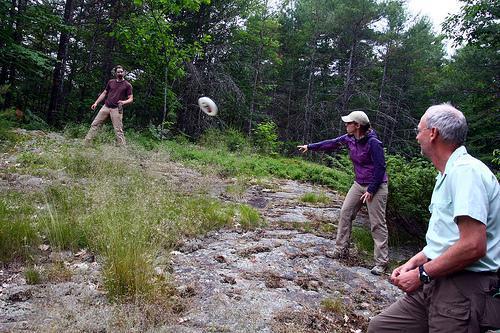How many people are there?
Give a very brief answer. 3. How many frisbees are there?
Give a very brief answer. 1. 